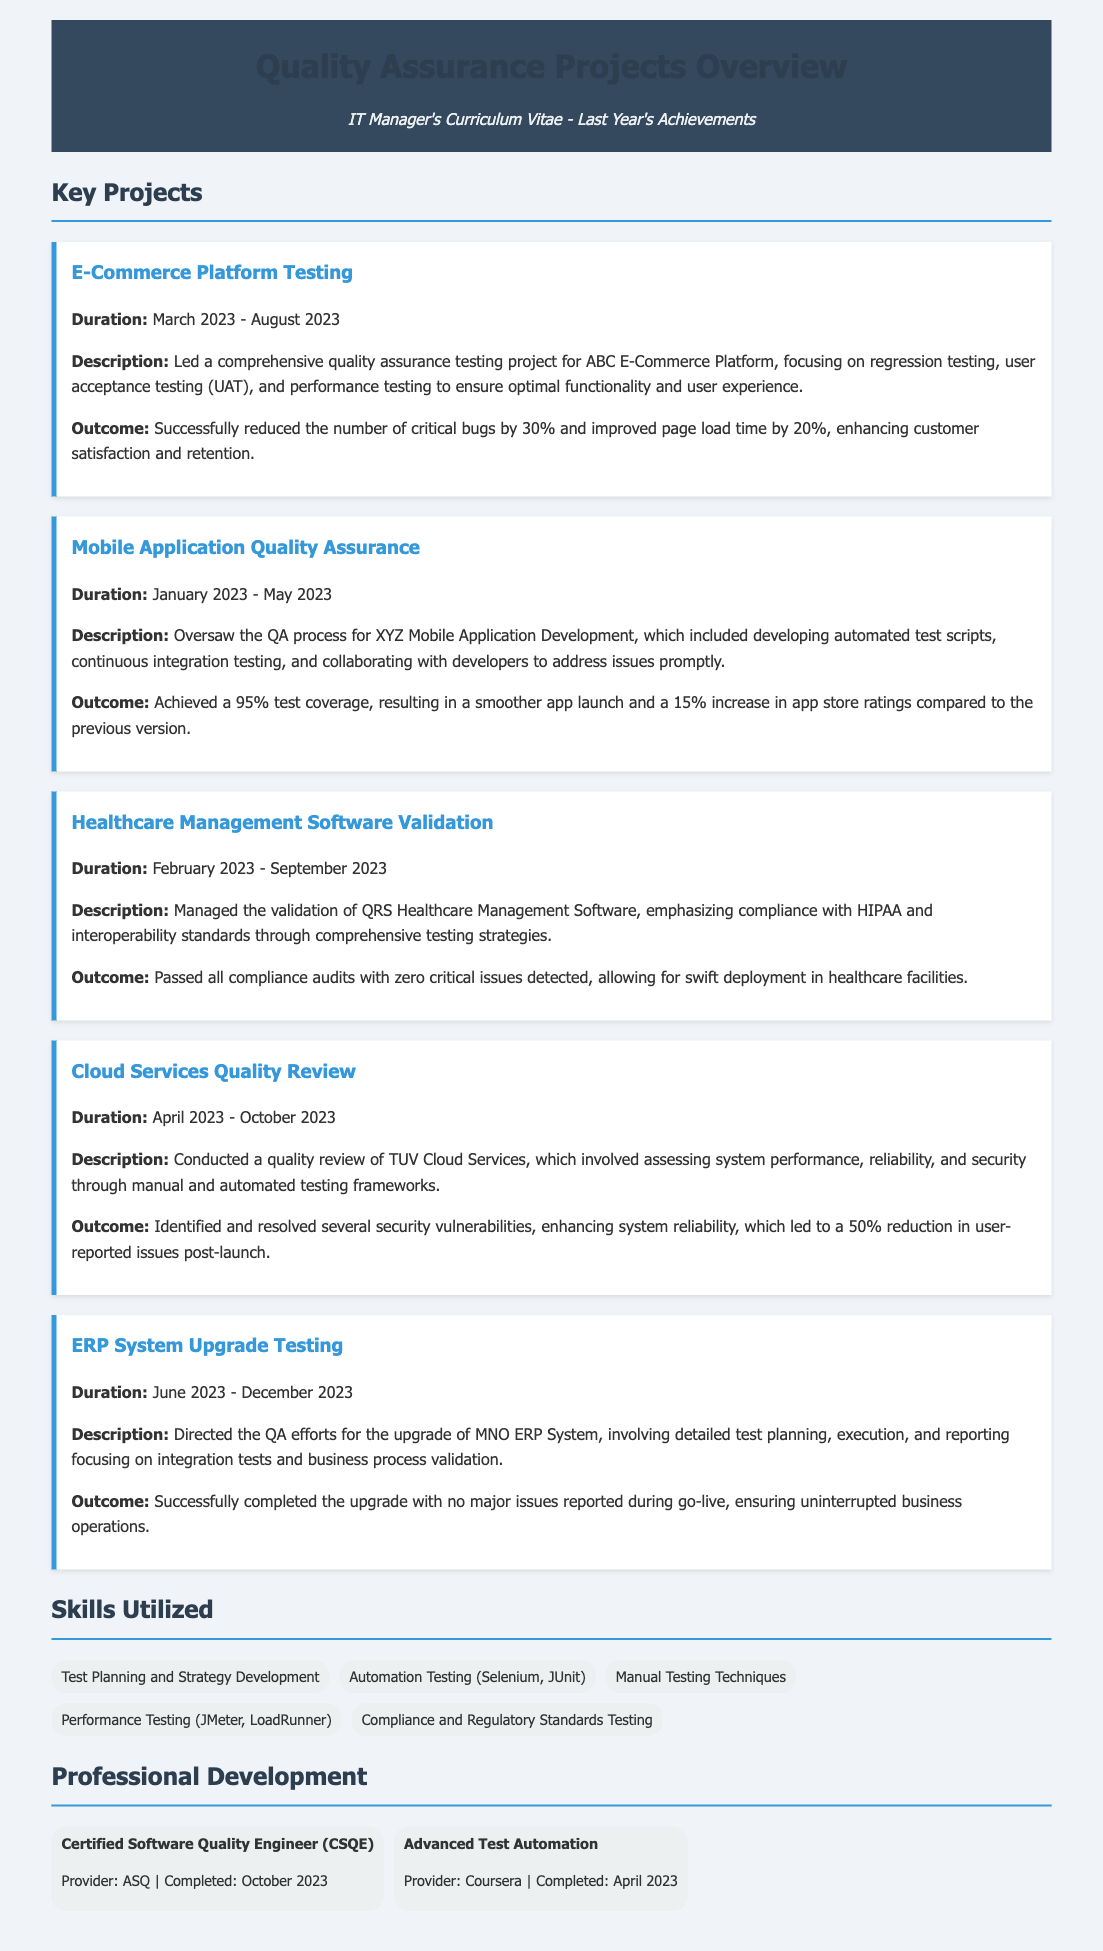what was the duration of the E-Commerce Platform Testing project? The duration is explicitly stated in the document as March 2023 - August 2023.
Answer: March 2023 - August 2023 what was the outcome of the Mobile Application Quality Assurance project? The document mentions that the outcome was a 95% test coverage and a 15% increase in app store ratings.
Answer: 95% test coverage, 15% increase in app store ratings which compliance standards were emphasized in the Healthcare Management Software Validation? The document highlights compliance with HIPAA and interoperability standards as key focuses.
Answer: HIPAA and interoperability standards what was the start date of the Cloud Services Quality Review project? The start date of the project is identified as April 2023 in the document.
Answer: April 2023 how many key projects are listed in the document? The document enumerates five key projects in the section titled "Key Projects."
Answer: Five what was the focus of the Quality Assurance efforts for the ERP System Upgrade Testing? According to the document, the focus was on integration tests and business process validation.
Answer: Integration tests and business process validation who was the provider of the Certified Software Quality Engineer course? The document specifies that the provider of the course was ASQ.
Answer: ASQ what percentage reduction in critical bugs was achieved in the E-Commerce Platform Testing project? The document reports a 30% reduction in critical bugs as the outcome of the project.
Answer: 30% reduction in critical bugs 